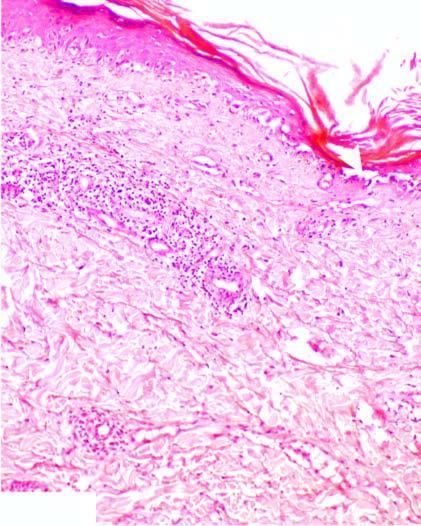does the basal layer show hydropic degeneration and loss of dermoepidermal junction?
Answer the question using a single word or phrase. Yes 